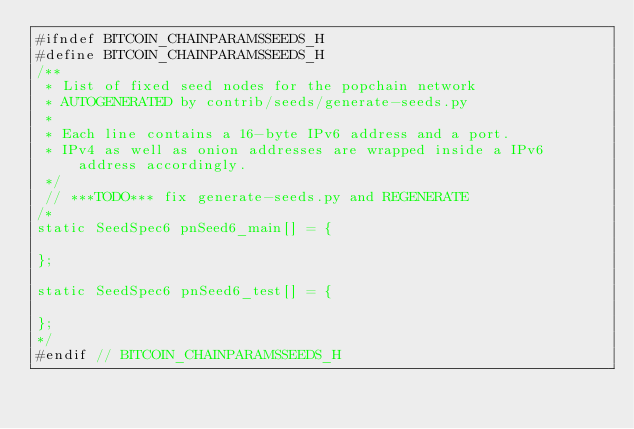Convert code to text. <code><loc_0><loc_0><loc_500><loc_500><_C_>#ifndef BITCOIN_CHAINPARAMSSEEDS_H
#define BITCOIN_CHAINPARAMSSEEDS_H
/**
 * List of fixed seed nodes for the popchain network
 * AUTOGENERATED by contrib/seeds/generate-seeds.py
 *
 * Each line contains a 16-byte IPv6 address and a port.
 * IPv4 as well as onion addresses are wrapped inside a IPv6 address accordingly.
 */
 // ***TODO*** fix generate-seeds.py and REGENERATE
/*
static SeedSpec6 pnSeed6_main[] = {

};

static SeedSpec6 pnSeed6_test[] = {

};
*/
#endif // BITCOIN_CHAINPARAMSSEEDS_H
</code> 